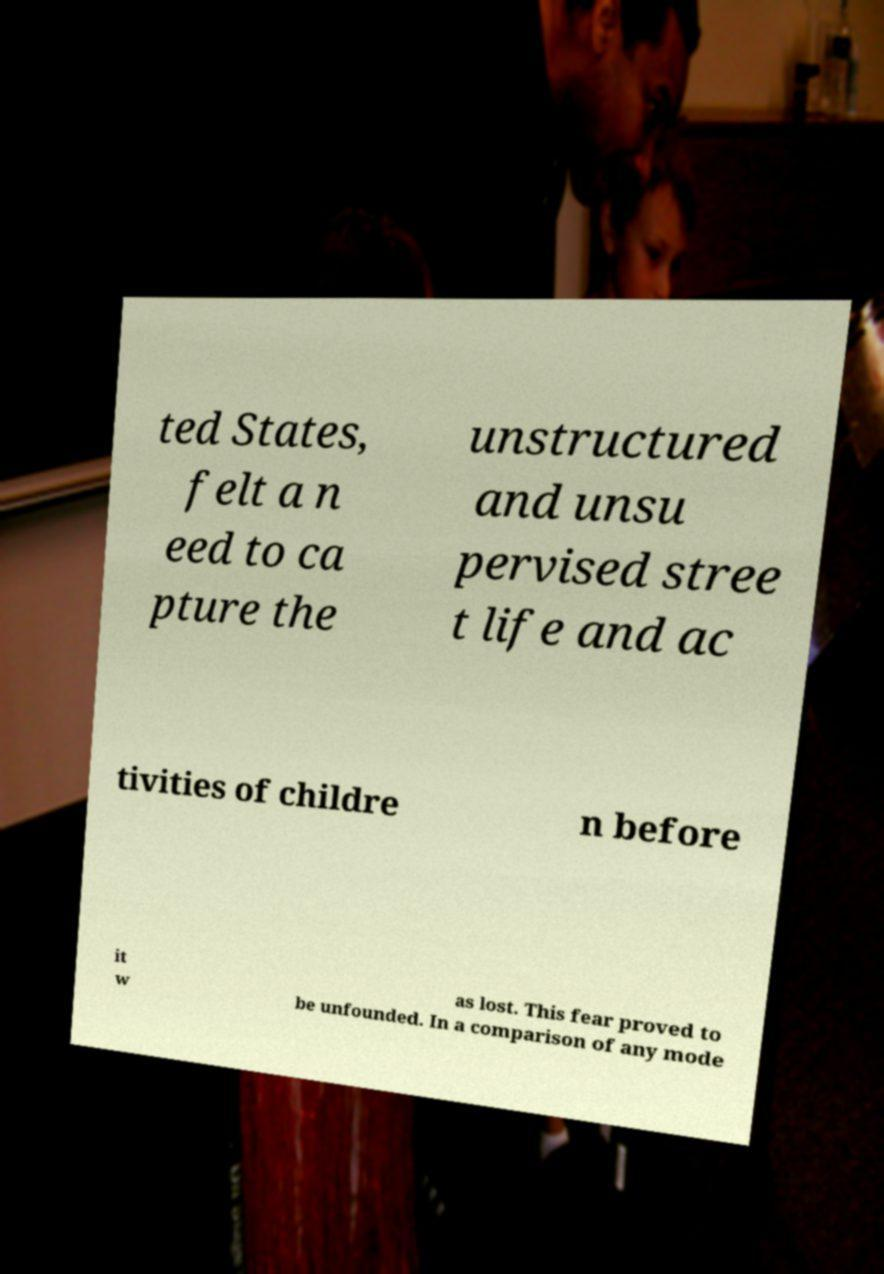What messages or text are displayed in this image? I need them in a readable, typed format. ted States, felt a n eed to ca pture the unstructured and unsu pervised stree t life and ac tivities of childre n before it w as lost. This fear proved to be unfounded. In a comparison of any mode 